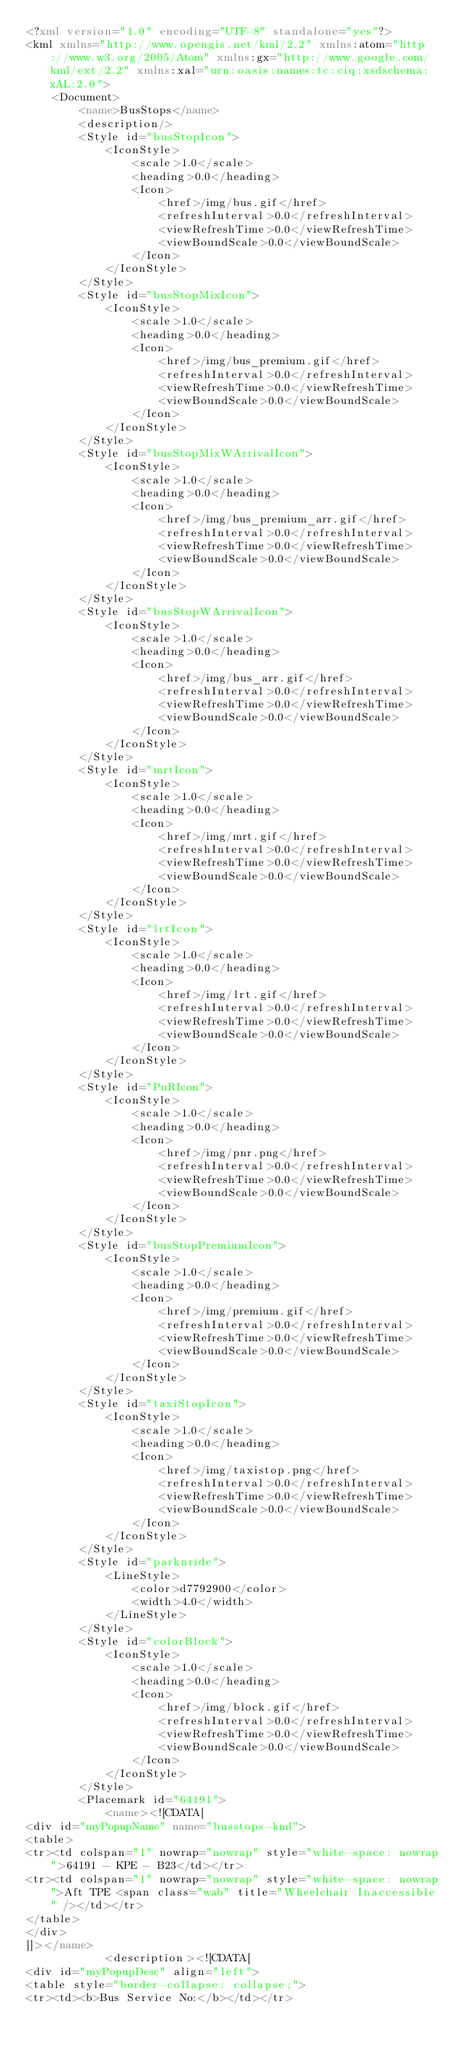<code> <loc_0><loc_0><loc_500><loc_500><_XML_><?xml version="1.0" encoding="UTF-8" standalone="yes"?>
<kml xmlns="http://www.opengis.net/kml/2.2" xmlns:atom="http://www.w3.org/2005/Atom" xmlns:gx="http://www.google.com/kml/ext/2.2" xmlns:xal="urn:oasis:names:tc:ciq:xsdschema:xAL:2.0">
    <Document>
        <name>BusStops</name>
        <description/>
        <Style id="busStopIcon">
            <IconStyle>
                <scale>1.0</scale>
                <heading>0.0</heading>
                <Icon>
                    <href>/img/bus.gif</href>
                    <refreshInterval>0.0</refreshInterval>
                    <viewRefreshTime>0.0</viewRefreshTime>
                    <viewBoundScale>0.0</viewBoundScale>
                </Icon>
            </IconStyle>
        </Style>
        <Style id="busStopMixIcon">
            <IconStyle>
                <scale>1.0</scale>
                <heading>0.0</heading>
                <Icon>
                    <href>/img/bus_premium.gif</href>
                    <refreshInterval>0.0</refreshInterval>
                    <viewRefreshTime>0.0</viewRefreshTime>
                    <viewBoundScale>0.0</viewBoundScale>
                </Icon>
            </IconStyle>
        </Style>
        <Style id="busStopMixWArrivalIcon">
            <IconStyle>
                <scale>1.0</scale>
                <heading>0.0</heading>
                <Icon>
                    <href>/img/bus_premium_arr.gif</href>
                    <refreshInterval>0.0</refreshInterval>
                    <viewRefreshTime>0.0</viewRefreshTime>
                    <viewBoundScale>0.0</viewBoundScale>
                </Icon>
            </IconStyle>
        </Style>
        <Style id="busStopWArrivalIcon">
            <IconStyle>
                <scale>1.0</scale>
                <heading>0.0</heading>
                <Icon>
                    <href>/img/bus_arr.gif</href>
                    <refreshInterval>0.0</refreshInterval>
                    <viewRefreshTime>0.0</viewRefreshTime>
                    <viewBoundScale>0.0</viewBoundScale>
                </Icon>
            </IconStyle>
        </Style>
        <Style id="mrtIcon">
            <IconStyle>
                <scale>1.0</scale>
                <heading>0.0</heading>
                <Icon>
                    <href>/img/mrt.gif</href>
                    <refreshInterval>0.0</refreshInterval>
                    <viewRefreshTime>0.0</viewRefreshTime>
                    <viewBoundScale>0.0</viewBoundScale>
                </Icon>
            </IconStyle>
        </Style>
        <Style id="lrtIcon">
            <IconStyle>
                <scale>1.0</scale>
                <heading>0.0</heading>
                <Icon>
                    <href>/img/lrt.gif</href>
                    <refreshInterval>0.0</refreshInterval>
                    <viewRefreshTime>0.0</viewRefreshTime>
                    <viewBoundScale>0.0</viewBoundScale>
                </Icon>
            </IconStyle>
        </Style>
        <Style id="PnRIcon">
            <IconStyle>
                <scale>1.0</scale>
                <heading>0.0</heading>
                <Icon>
                    <href>/img/pnr.png</href>
                    <refreshInterval>0.0</refreshInterval>
                    <viewRefreshTime>0.0</viewRefreshTime>
                    <viewBoundScale>0.0</viewBoundScale>
                </Icon>
            </IconStyle>
        </Style>
        <Style id="busStopPremiumIcon">
            <IconStyle>
                <scale>1.0</scale>
                <heading>0.0</heading>
                <Icon>
                    <href>/img/premium.gif</href>
                    <refreshInterval>0.0</refreshInterval>
                    <viewRefreshTime>0.0</viewRefreshTime>
                    <viewBoundScale>0.0</viewBoundScale>
                </Icon>
            </IconStyle>
        </Style>
        <Style id="taxiStopIcon">
            <IconStyle>
                <scale>1.0</scale>
                <heading>0.0</heading>
                <Icon>
                    <href>/img/taxistop.png</href>
                    <refreshInterval>0.0</refreshInterval>
                    <viewRefreshTime>0.0</viewRefreshTime>
                    <viewBoundScale>0.0</viewBoundScale>
                </Icon>
            </IconStyle>
        </Style>
        <Style id="parknride">
            <LineStyle>
                <color>d7792900</color>
                <width>4.0</width>
            </LineStyle>
        </Style>
        <Style id="colorBlock">
            <IconStyle>
                <scale>1.0</scale>
                <heading>0.0</heading>
                <Icon>
                    <href>/img/block.gif</href>
                    <refreshInterval>0.0</refreshInterval>
                    <viewRefreshTime>0.0</viewRefreshTime>
                    <viewBoundScale>0.0</viewBoundScale>
                </Icon>
            </IconStyle>
        </Style>
        <Placemark id="64191">
            <name><![CDATA[
<div id="myPopupName" name="busstops-kml">
<table>
<tr><td colspan="1" nowrap="nowrap" style="white-space: nowrap">64191 - KPE - B23</td></tr>
<tr><td colspan="1" nowrap="nowrap" style="white-space: nowrap">Aft TPE <span class="wab" title="Wheelchair Inaccessible" /></td></tr>
</table>
</div>
]]></name>
            <description><![CDATA[
<div id="myPopupDesc" align="left">
<table style="border-collapse: collapse;">
<tr><td><b>Bus Service No:</b></td></tr></code> 